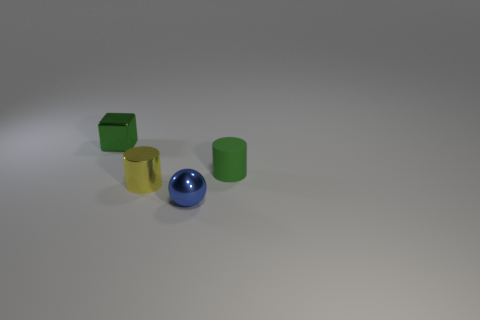Add 4 metallic cylinders. How many objects exist? 8 Subtract all balls. How many objects are left? 3 Subtract all brown blocks. How many yellow cylinders are left? 1 Subtract 0 blue cylinders. How many objects are left? 4 Subtract all yellow cylinders. Subtract all cyan spheres. How many cylinders are left? 1 Subtract all purple cylinders. Subtract all small things. How many objects are left? 0 Add 2 tiny green cylinders. How many tiny green cylinders are left? 3 Add 1 small rubber cylinders. How many small rubber cylinders exist? 2 